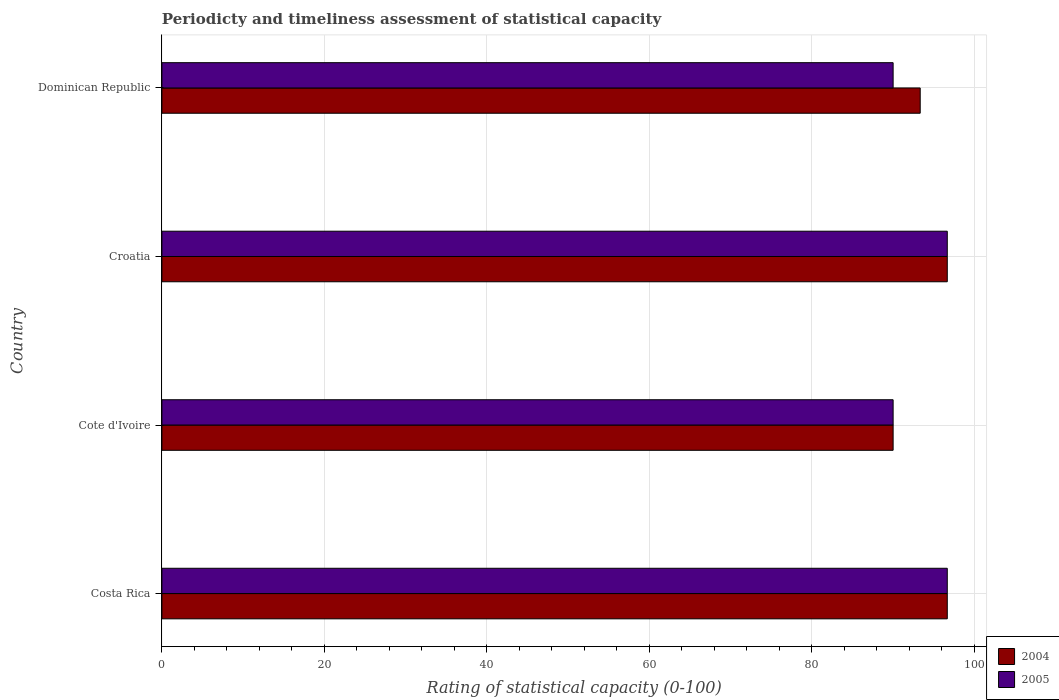Are the number of bars on each tick of the Y-axis equal?
Make the answer very short. Yes. What is the label of the 1st group of bars from the top?
Ensure brevity in your answer.  Dominican Republic. What is the rating of statistical capacity in 2005 in Croatia?
Give a very brief answer. 96.67. Across all countries, what is the maximum rating of statistical capacity in 2004?
Ensure brevity in your answer.  96.67. Across all countries, what is the minimum rating of statistical capacity in 2004?
Provide a short and direct response. 90. In which country was the rating of statistical capacity in 2005 maximum?
Keep it short and to the point. Costa Rica. In which country was the rating of statistical capacity in 2004 minimum?
Offer a terse response. Cote d'Ivoire. What is the total rating of statistical capacity in 2004 in the graph?
Keep it short and to the point. 376.67. What is the difference between the rating of statistical capacity in 2005 in Costa Rica and the rating of statistical capacity in 2004 in Cote d'Ivoire?
Give a very brief answer. 6.67. What is the average rating of statistical capacity in 2005 per country?
Keep it short and to the point. 93.33. What is the difference between the rating of statistical capacity in 2005 and rating of statistical capacity in 2004 in Cote d'Ivoire?
Your answer should be compact. 0. What is the ratio of the rating of statistical capacity in 2004 in Cote d'Ivoire to that in Croatia?
Your response must be concise. 0.93. What is the difference between the highest and the second highest rating of statistical capacity in 2005?
Provide a short and direct response. 0. What is the difference between the highest and the lowest rating of statistical capacity in 2005?
Make the answer very short. 6.67. In how many countries, is the rating of statistical capacity in 2005 greater than the average rating of statistical capacity in 2005 taken over all countries?
Provide a succinct answer. 2. Is the sum of the rating of statistical capacity in 2005 in Costa Rica and Croatia greater than the maximum rating of statistical capacity in 2004 across all countries?
Your answer should be compact. Yes. What does the 1st bar from the top in Cote d'Ivoire represents?
Provide a succinct answer. 2005. How many bars are there?
Make the answer very short. 8. Are all the bars in the graph horizontal?
Provide a short and direct response. Yes. How many countries are there in the graph?
Offer a very short reply. 4. Does the graph contain grids?
Ensure brevity in your answer.  Yes. Where does the legend appear in the graph?
Give a very brief answer. Bottom right. What is the title of the graph?
Keep it short and to the point. Periodicty and timeliness assessment of statistical capacity. What is the label or title of the X-axis?
Make the answer very short. Rating of statistical capacity (0-100). What is the label or title of the Y-axis?
Give a very brief answer. Country. What is the Rating of statistical capacity (0-100) of 2004 in Costa Rica?
Offer a terse response. 96.67. What is the Rating of statistical capacity (0-100) in 2005 in Costa Rica?
Make the answer very short. 96.67. What is the Rating of statistical capacity (0-100) in 2004 in Cote d'Ivoire?
Make the answer very short. 90. What is the Rating of statistical capacity (0-100) of 2004 in Croatia?
Your answer should be compact. 96.67. What is the Rating of statistical capacity (0-100) in 2005 in Croatia?
Provide a short and direct response. 96.67. What is the Rating of statistical capacity (0-100) in 2004 in Dominican Republic?
Provide a succinct answer. 93.33. What is the Rating of statistical capacity (0-100) in 2005 in Dominican Republic?
Your answer should be compact. 90. Across all countries, what is the maximum Rating of statistical capacity (0-100) in 2004?
Your response must be concise. 96.67. Across all countries, what is the maximum Rating of statistical capacity (0-100) of 2005?
Your answer should be very brief. 96.67. Across all countries, what is the minimum Rating of statistical capacity (0-100) of 2005?
Provide a succinct answer. 90. What is the total Rating of statistical capacity (0-100) in 2004 in the graph?
Ensure brevity in your answer.  376.67. What is the total Rating of statistical capacity (0-100) of 2005 in the graph?
Provide a succinct answer. 373.33. What is the difference between the Rating of statistical capacity (0-100) of 2005 in Costa Rica and that in Cote d'Ivoire?
Offer a very short reply. 6.67. What is the difference between the Rating of statistical capacity (0-100) in 2004 in Costa Rica and that in Croatia?
Ensure brevity in your answer.  0. What is the difference between the Rating of statistical capacity (0-100) in 2005 in Costa Rica and that in Croatia?
Provide a short and direct response. 0. What is the difference between the Rating of statistical capacity (0-100) in 2004 in Cote d'Ivoire and that in Croatia?
Provide a succinct answer. -6.67. What is the difference between the Rating of statistical capacity (0-100) in 2005 in Cote d'Ivoire and that in Croatia?
Your response must be concise. -6.67. What is the difference between the Rating of statistical capacity (0-100) of 2005 in Cote d'Ivoire and that in Dominican Republic?
Your response must be concise. 0. What is the difference between the Rating of statistical capacity (0-100) in 2004 in Croatia and that in Dominican Republic?
Give a very brief answer. 3.33. What is the difference between the Rating of statistical capacity (0-100) in 2004 in Costa Rica and the Rating of statistical capacity (0-100) in 2005 in Cote d'Ivoire?
Offer a terse response. 6.67. What is the difference between the Rating of statistical capacity (0-100) in 2004 in Cote d'Ivoire and the Rating of statistical capacity (0-100) in 2005 in Croatia?
Provide a short and direct response. -6.67. What is the difference between the Rating of statistical capacity (0-100) of 2004 in Cote d'Ivoire and the Rating of statistical capacity (0-100) of 2005 in Dominican Republic?
Keep it short and to the point. 0. What is the average Rating of statistical capacity (0-100) of 2004 per country?
Keep it short and to the point. 94.17. What is the average Rating of statistical capacity (0-100) of 2005 per country?
Provide a succinct answer. 93.33. What is the difference between the Rating of statistical capacity (0-100) in 2004 and Rating of statistical capacity (0-100) in 2005 in Costa Rica?
Make the answer very short. 0. What is the difference between the Rating of statistical capacity (0-100) in 2004 and Rating of statistical capacity (0-100) in 2005 in Cote d'Ivoire?
Provide a short and direct response. 0. What is the difference between the Rating of statistical capacity (0-100) of 2004 and Rating of statistical capacity (0-100) of 2005 in Croatia?
Your response must be concise. 0. What is the difference between the Rating of statistical capacity (0-100) of 2004 and Rating of statistical capacity (0-100) of 2005 in Dominican Republic?
Your response must be concise. 3.33. What is the ratio of the Rating of statistical capacity (0-100) of 2004 in Costa Rica to that in Cote d'Ivoire?
Offer a very short reply. 1.07. What is the ratio of the Rating of statistical capacity (0-100) in 2005 in Costa Rica to that in Cote d'Ivoire?
Provide a succinct answer. 1.07. What is the ratio of the Rating of statistical capacity (0-100) of 2004 in Costa Rica to that in Croatia?
Your answer should be very brief. 1. What is the ratio of the Rating of statistical capacity (0-100) in 2004 in Costa Rica to that in Dominican Republic?
Offer a very short reply. 1.04. What is the ratio of the Rating of statistical capacity (0-100) of 2005 in Costa Rica to that in Dominican Republic?
Keep it short and to the point. 1.07. What is the ratio of the Rating of statistical capacity (0-100) of 2004 in Cote d'Ivoire to that in Croatia?
Ensure brevity in your answer.  0.93. What is the ratio of the Rating of statistical capacity (0-100) in 2004 in Cote d'Ivoire to that in Dominican Republic?
Make the answer very short. 0.96. What is the ratio of the Rating of statistical capacity (0-100) in 2005 in Cote d'Ivoire to that in Dominican Republic?
Provide a short and direct response. 1. What is the ratio of the Rating of statistical capacity (0-100) in 2004 in Croatia to that in Dominican Republic?
Your response must be concise. 1.04. What is the ratio of the Rating of statistical capacity (0-100) of 2005 in Croatia to that in Dominican Republic?
Your response must be concise. 1.07. What is the difference between the highest and the second highest Rating of statistical capacity (0-100) of 2004?
Make the answer very short. 0. 